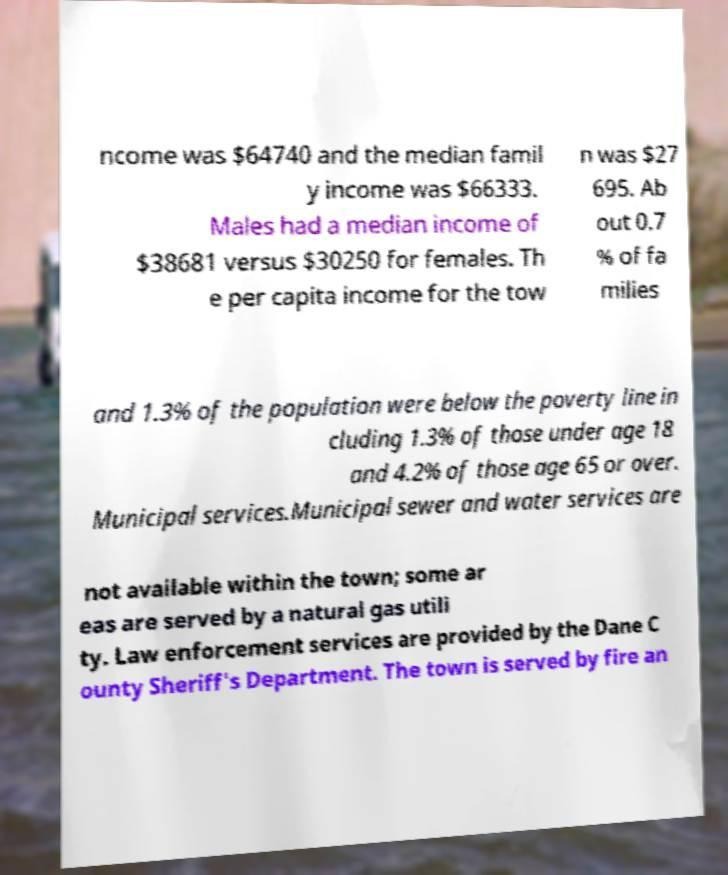There's text embedded in this image that I need extracted. Can you transcribe it verbatim? ncome was $64740 and the median famil y income was $66333. Males had a median income of $38681 versus $30250 for females. Th e per capita income for the tow n was $27 695. Ab out 0.7 % of fa milies and 1.3% of the population were below the poverty line in cluding 1.3% of those under age 18 and 4.2% of those age 65 or over. Municipal services.Municipal sewer and water services are not available within the town; some ar eas are served by a natural gas utili ty. Law enforcement services are provided by the Dane C ounty Sheriff's Department. The town is served by fire an 